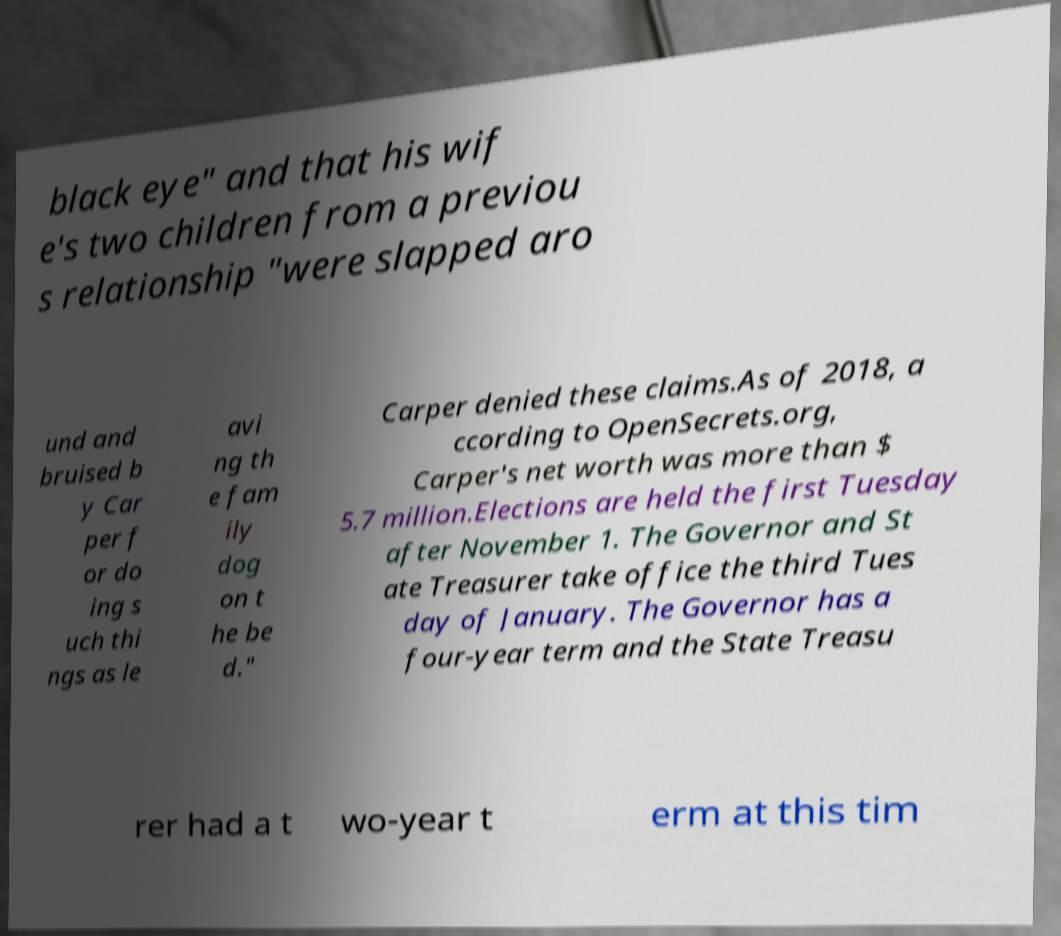Please read and relay the text visible in this image. What does it say? black eye" and that his wif e's two children from a previou s relationship "were slapped aro und and bruised b y Car per f or do ing s uch thi ngs as le avi ng th e fam ily dog on t he be d." Carper denied these claims.As of 2018, a ccording to OpenSecrets.org, Carper's net worth was more than $ 5.7 million.Elections are held the first Tuesday after November 1. The Governor and St ate Treasurer take office the third Tues day of January. The Governor has a four-year term and the State Treasu rer had a t wo-year t erm at this tim 